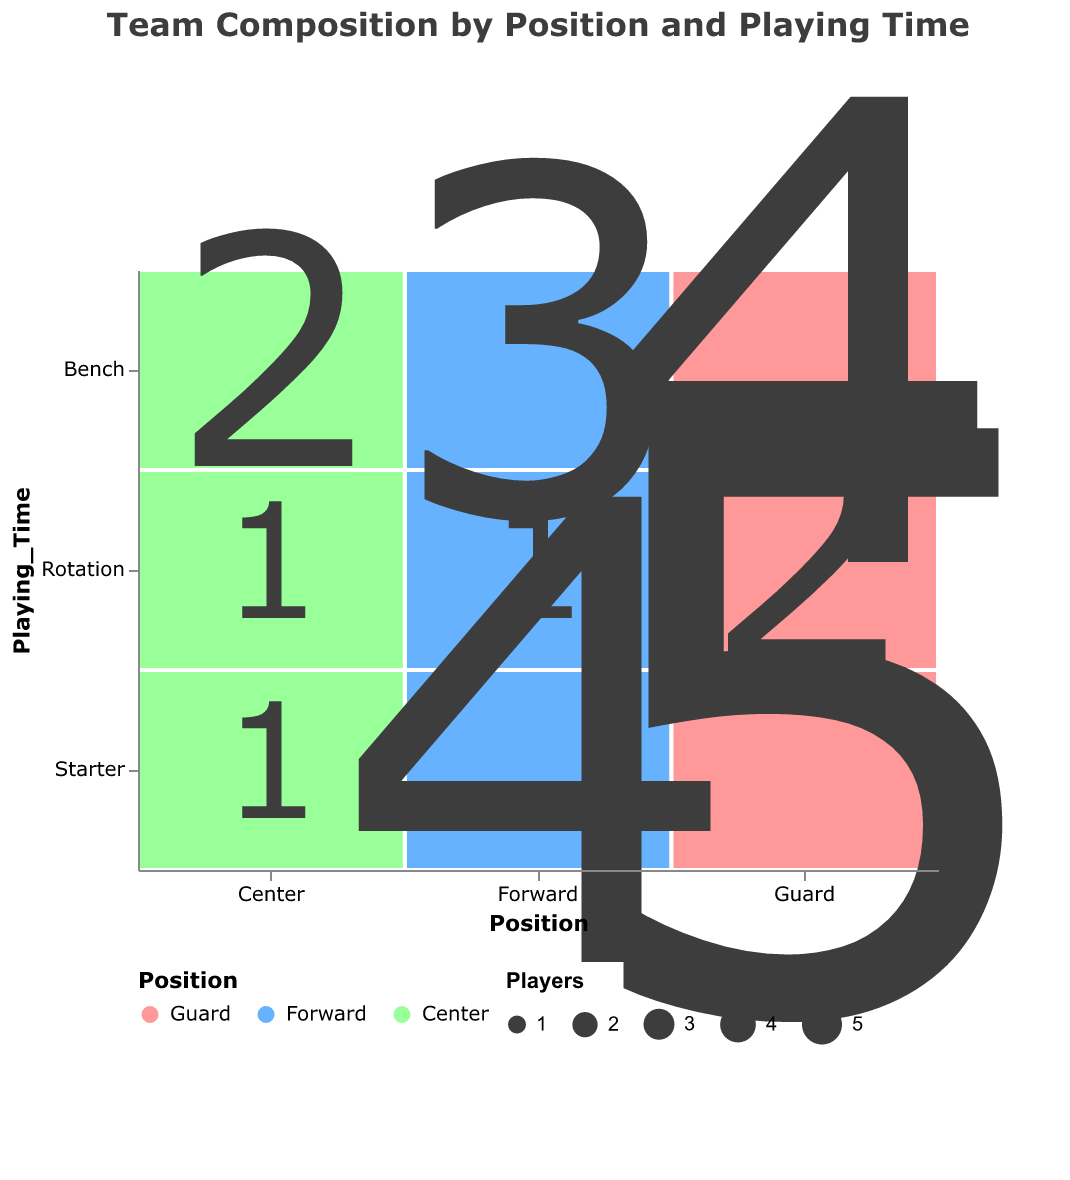What's the title of the figure? The title is usually a text element that describes the content or the purpose of the plot. In this case, it can be found at the top of the plot in a larger font.
Answer: Team Composition by Position and Playing Time Which position has the most starters? To answer this, look at the "Starter" row and identify the highest number listed in each "Position" column. Guards have the number 5, which is the highest.
Answer: Guards How many Guards are there overall? Sum up the number of players in the Guard position from all playing time categories (Starter, Bench, Rotation). This is 5 (Starter) + 4 (Bench) + 2 (Rotation).
Answer: 11 Which playing time has the least number of Forwards? For this, check each cell under the Forward position and identify the smallest value. The values are 4 (Starter), 3 (Bench), and 1 (Rotation). The least is 1 for Rotation.
Answer: Rotation Compare the number of Bench players for Center and Forward. Which has more? Locate the Bench row for both positions and compare the numbers. Center has 2, and Forward has 3, so Forward has more.
Answer: Forward How many total players are on the Bench? Add the number of players on the Bench for all positions. This is 4 (Guard) + 3 (Forward) + 2 (Center).
Answer: 9 What is the proportion of starting Guards to starting players for all positions? Calculate the number of starting Guards (5) and then sum the starters for all positions (5 Guards + 4 Forwards + 1 Center = 10). The proportion is 5/10.
Answer: 50% Which playing time category has the fewest players overall? Sum the players in each playing time category. Starters: 5+4+1=10, Bench: 4+3+2=9, Rotation: 2+1+1=4. The fewest is Rotation.
Answer: Rotation Which position has an equal number of players in all playing time categories? Check each playing time category for all positions and see if any position has the same number. No position has equal numbers across all categories.
Answer: None 